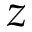Convert formula to latex. <formula><loc_0><loc_0><loc_500><loc_500>z</formula> 